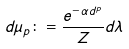<formula> <loc_0><loc_0><loc_500><loc_500>d \mu _ { p } \colon = \frac { e ^ { - \alpha d ^ { p } } } { Z } d \lambda</formula> 